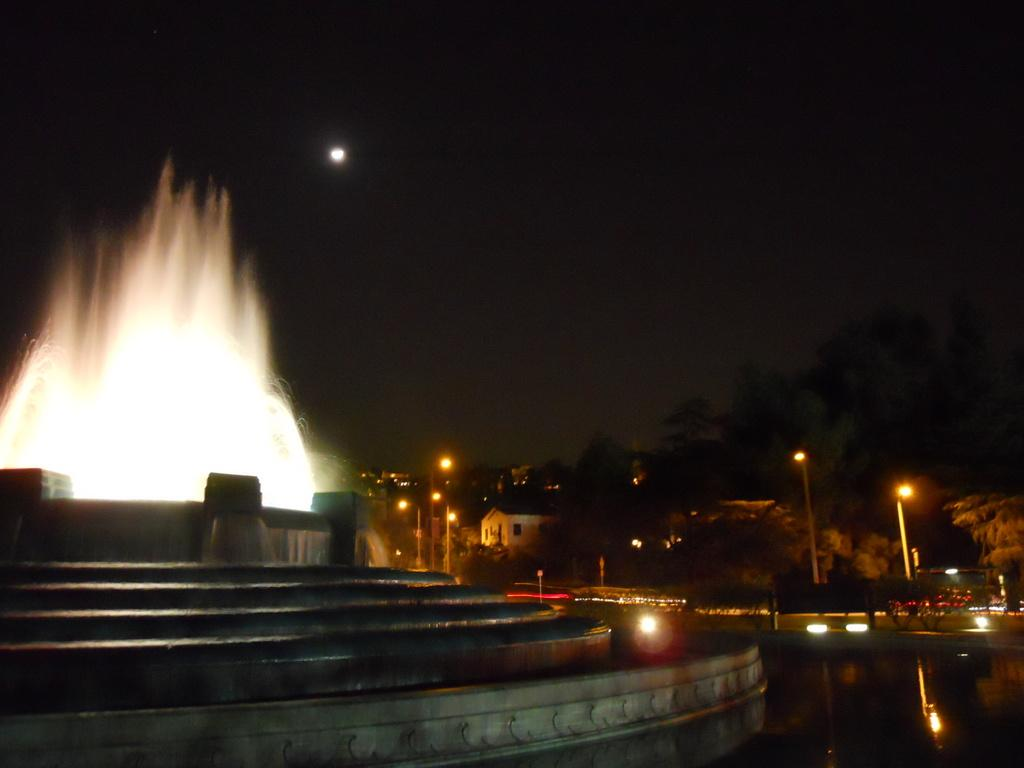What type of natural elements can be seen in the image? There are trees in the image. What type of man-made structures are present in the image? There are buildings in the image. What is located in the center of the image? There is a water fountain in the center of the image. Are there any architectural features in the image? Yes, there are steps in the image. What celestial body is visible in the sky? The moon is visible in the sky. What type of meal is being prepared by the daughter in the image? There is no daughter present in the image, and no meal preparation is depicted. How does the water fountain move in the image? The water fountain does not move in the image; it is stationary. 